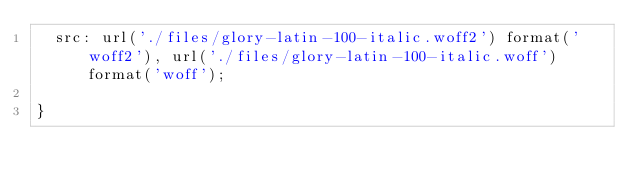<code> <loc_0><loc_0><loc_500><loc_500><_CSS_>  src: url('./files/glory-latin-100-italic.woff2') format('woff2'), url('./files/glory-latin-100-italic.woff') format('woff');
  
}
</code> 